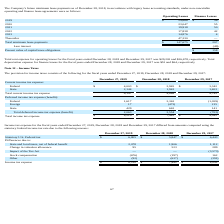From Chefs Wharehouse's financial document, What is the total current income tax expense for 2019, 2018 and 2017 respectively? The document contains multiple relevant values: 6,147, 4,888, 4,745. From the document: "Total current income tax expense 6,147 4,888 4,745 Total current income tax expense 6,147 4,888 4,745 Total current income tax expense 6,147 4,888 4,7..." Also, What is the total income tax expense for 2019, 2018 and 2017 respectively? The document contains multiple relevant values: $8,210, $7,442, $4,042. From the document: "Total income tax expense $ 8,210 $ 7,442 $ 4,042 Total income tax expense $ 8,210 $ 7,442 $ 4,042 Total income tax expense $ 8,210 $ 7,442 $ 4,042..." Also, What is the Total deferred income tax expense (benefit) for 2019, 2018 and 2017 respectively? The document contains multiple relevant values: 2,063, 2,554, (703). From the document: "Total deferred income tax expense (benefit) 2,063 2,554 (703) Total deferred income tax expense (benefit) 2,063 2,554 (703) deferred income tax expens..." Also, can you calculate: What is the change in total income tax expense between 2019 and 2018? Based on the calculation: 8,210-7,442, the result is 768. This is based on the information: "Total income tax expense $ 8,210 $ 7,442 $ 4,042 Total income tax expense $ 8,210 $ 7,442 $ 4,042..." The key data points involved are: 7,442, 8,210. Also, can you calculate: What is the average Total income tax expense for 2019, 2018 and 2017? To answer this question, I need to perform calculations using the financial data. The calculation is: (8,210+ 7,442+ 4,042)/3, which equals 6564.67. This is based on the information: "Total income tax expense $ 8,210 $ 7,442 $ 4,042 Total income tax expense $ 8,210 $ 7,442 $ 4,042 Total income tax expense $ 8,210 $ 7,442 $ 4,042..." The key data points involved are: 4,042, 7,442, 8,210. Additionally, Which year has the highest Total income tax expense? According to the financial document, 2019. The relevant text states: "December 27, 2019 December 28, 2018 December 29, 2017..." 